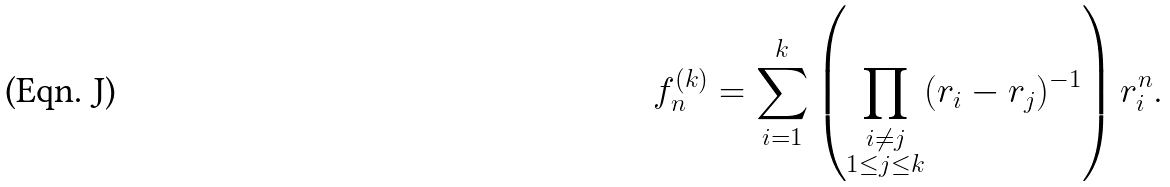Convert formula to latex. <formula><loc_0><loc_0><loc_500><loc_500>f _ { n } ^ { ( k ) } = \sum _ { i = 1 } ^ { k } \left ( \prod _ { \substack { i \neq j \\ 1 \leq j \leq k } } ( r _ { i } - r _ { j } ) ^ { - 1 } \right ) r _ { i } ^ { n } .</formula> 